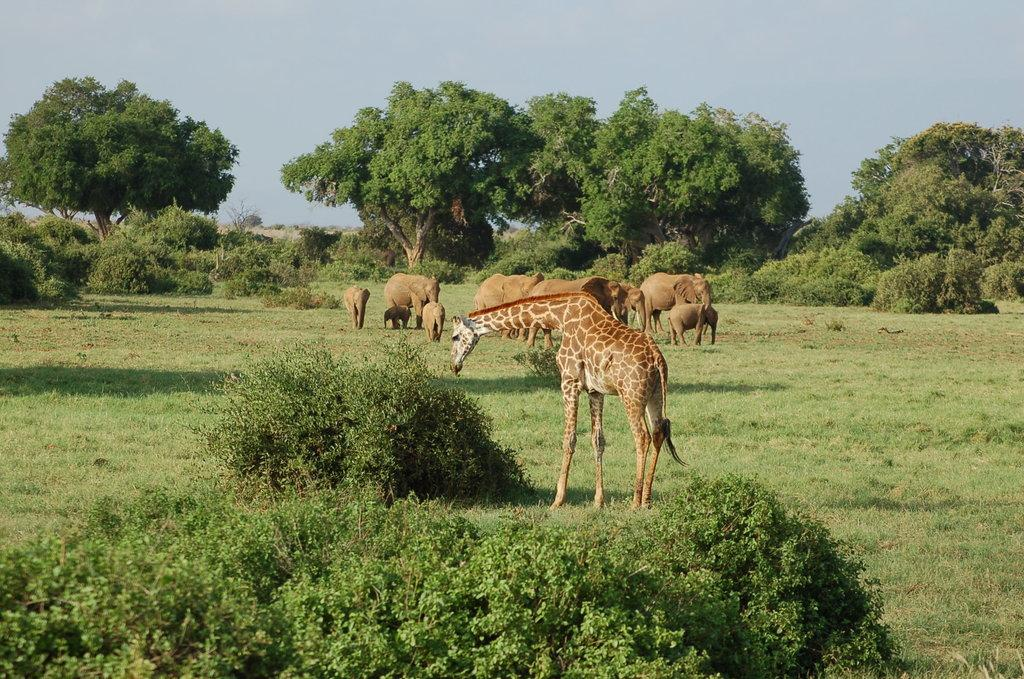What type of animals can be seen in the image? There is a group of animals in the image, including elephants and a giraffe. What is the position of the animals in the image? The animals are standing on the ground. What can be seen in the background of the image? There is a group of trees and the sky visible in the background of the image. What type of stocking is the giraffe wearing in the image? There is no stocking present on the giraffe in the image. Can you tell me how the animals are driving in the image? The animals are not driving in the image; they are standing on the ground. 